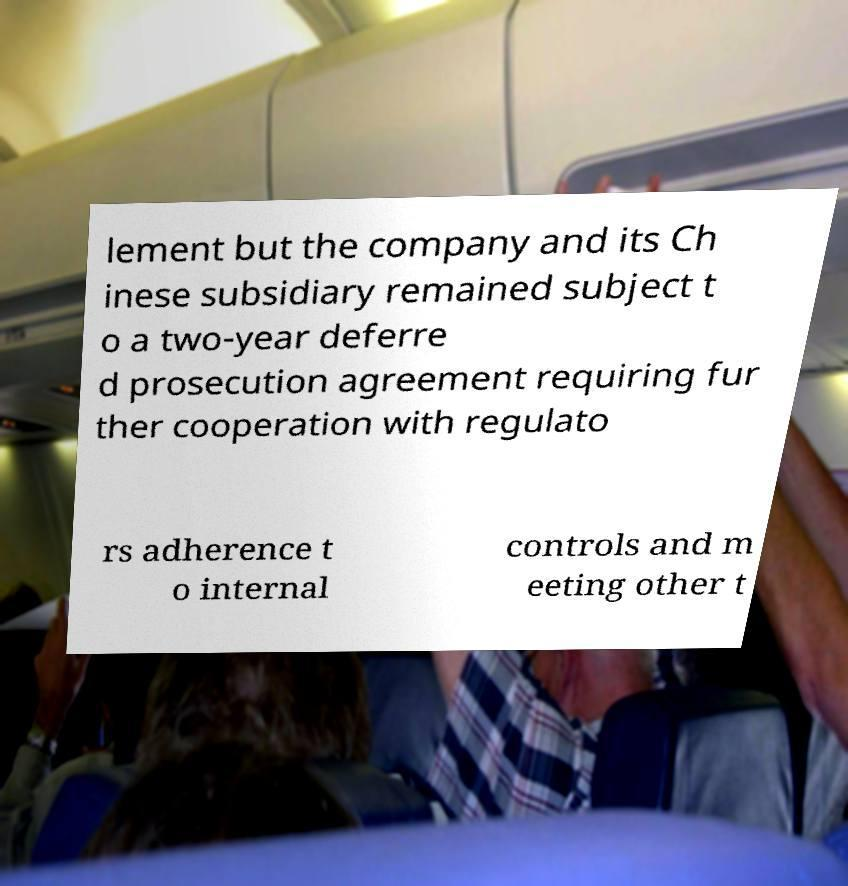There's text embedded in this image that I need extracted. Can you transcribe it verbatim? lement but the company and its Ch inese subsidiary remained subject t o a two-year deferre d prosecution agreement requiring fur ther cooperation with regulato rs adherence t o internal controls and m eeting other t 